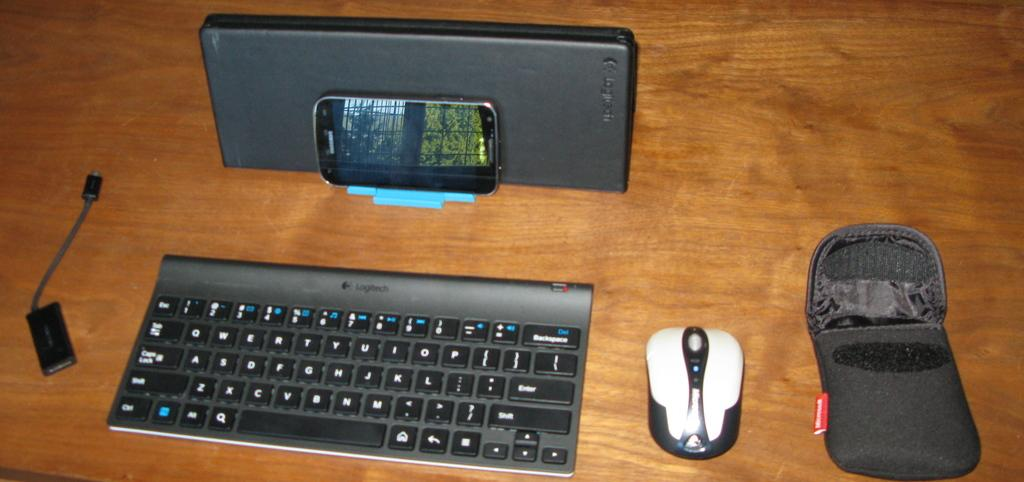What is: What type of input device is visible in the image? There is a keyboard in the image. What other input device is present in the image? There is a mouse in the image. What communication device can be seen in the image? There is a phone in the image. What type of cable is visible in the image? There is a USB cable in the image. What small accessory is present in the image? There is a small pouch in the image. What type of ring is on the hand in the image? There is no hand or ring present in the image. Where is the bed located in the image? There is no bed present in the image. 